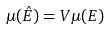<formula> <loc_0><loc_0><loc_500><loc_500>\mu ( \hat { E } ) = V \mu ( E )</formula> 